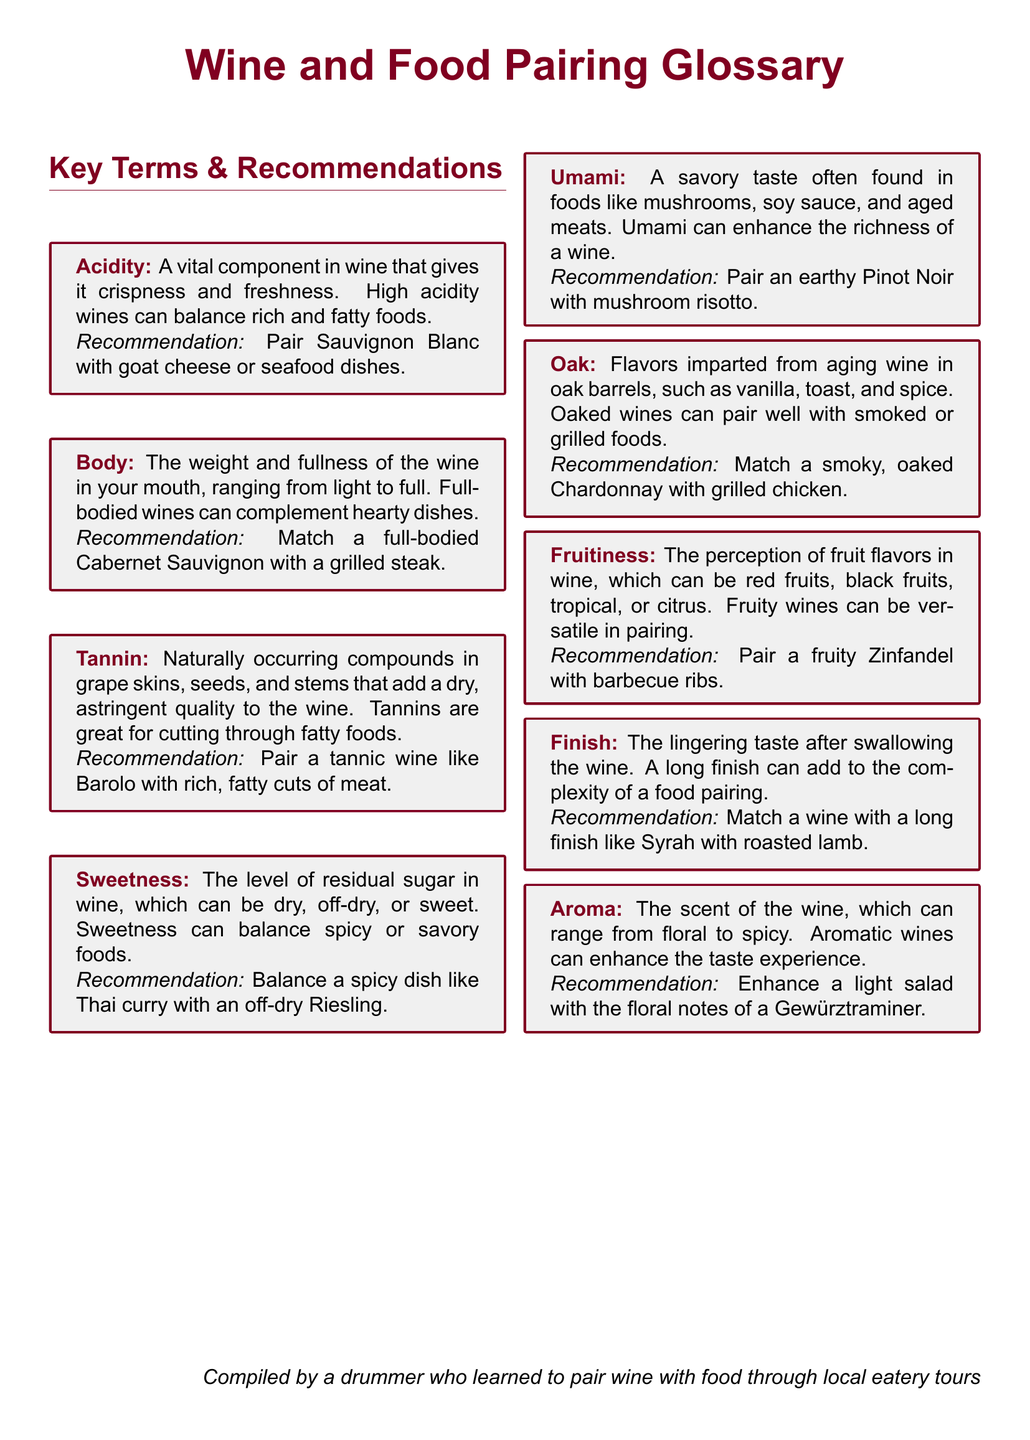What is acidity? Acidity is a vital component in wine that gives it crispness and freshness.
Answer: A vital component in wine that gives it crispness and freshness What wine pairs well with goat cheese? The document recommends pairing Sauvignon Blanc with goat cheese.
Answer: Sauvignon Blanc What does the term 'body' refer to in wine? Body refers to the weight and fullness of the wine in your mouth, ranging from light to full.
Answer: Weight and fullness What food is recommended to pair with Barolo? The document suggests pairing Barolo with rich, fatty cuts of meat.
Answer: Rich, fatty cuts of meat What is umami? Umami is a savory taste often found in foods like mushrooms, soy sauce, and aged meats.
Answer: A savory taste What flavor notes can oak impart in wine? Flavors imparted from aging wine in oak barrels can include vanilla, toast, and spice.
Answer: Vanilla, toast, and spice Which wine is suggested for grilled chicken? A smoky, oaked Chardonnay is recommended for pairing with grilled chicken.
Answer: Smoky, oaked Chardonnay What does 'finish' mean in wine tasting? Finish refers to the lingering taste after swallowing the wine.
Answer: Lingering taste Which style of dish should be matched with a fruity Zinfandel? The document recommends pairing a fruity Zinfandel with barbecue ribs.
Answer: Barbecue ribs What is the role of aroma in wine? Aroma can enhance the taste experience of the wine.
Answer: Enhance the taste experience 